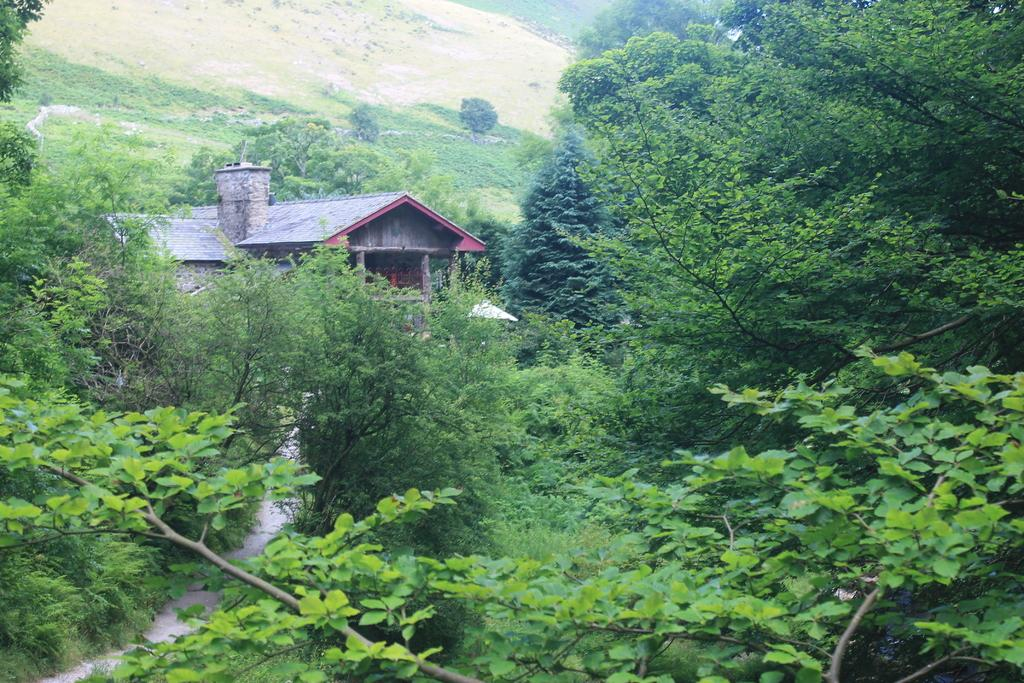What type of structure is visible in the image? There is a building in the image. What natural elements can be seen in the image? There are trees and grass in the image. How many grapes are hanging from the trees in the image? There are no grapes visible in the image; only trees are present. What type of chair can be seen in the image? There is no chair present in the image. 